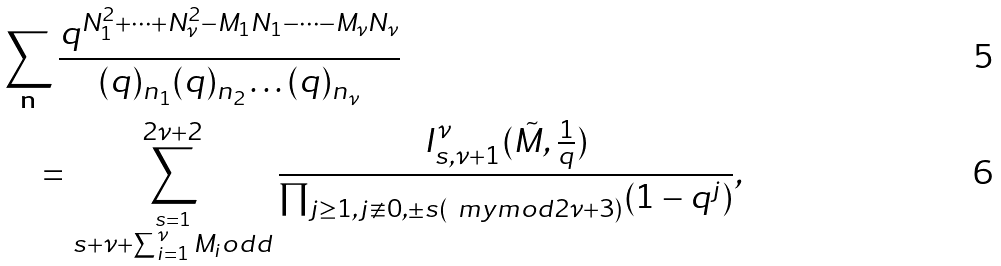Convert formula to latex. <formula><loc_0><loc_0><loc_500><loc_500>& \sum _ { \mathbf n } \frac { q ^ { N _ { 1 } ^ { 2 } + \cdots + N _ { \nu } ^ { 2 } - M _ { 1 } N _ { 1 } - \cdots - M _ { \nu } N _ { \nu } } } { ( q ) _ { n _ { 1 } } ( q ) _ { n _ { 2 } } \dots ( q ) _ { n _ { \nu } } } \\ & \quad = \sum _ { \stackrel { s = 1 } { s + \nu + \sum _ { i = 1 } ^ { \nu } M _ { i } o d d } } ^ { 2 \nu + 2 } \frac { I _ { s , \nu + 1 } ^ { \nu } ( \tilde { M } , \frac { 1 } { q } ) } { \prod _ { j \geq 1 , j \not \equiv 0 , \pm s ( \ m y m o d 2 \nu + 3 ) } ( 1 - q ^ { j } ) } ,</formula> 